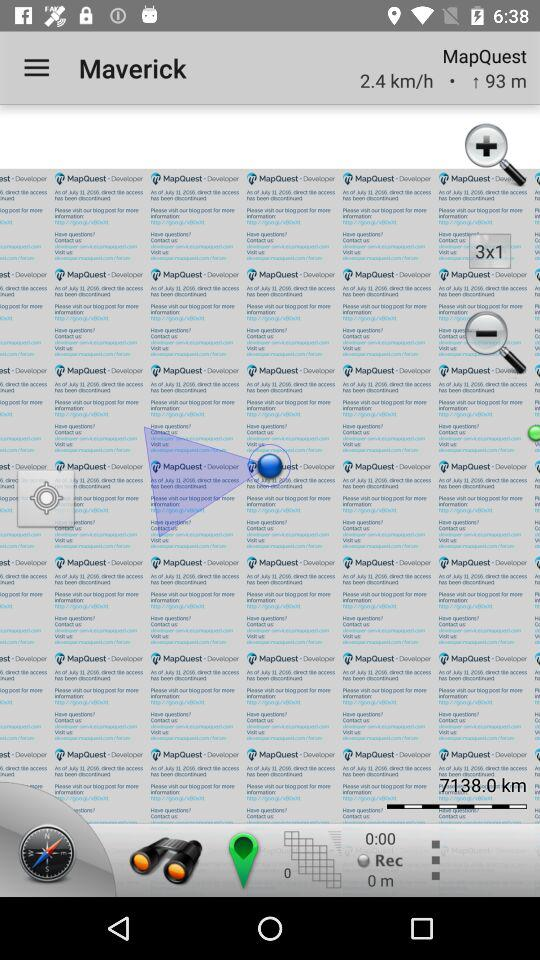What is the duration of recording?
When the provided information is insufficient, respond with <no answer>. <no answer> 